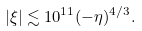Convert formula to latex. <formula><loc_0><loc_0><loc_500><loc_500>| \xi | \lesssim 1 0 ^ { 1 1 } ( - \eta ) ^ { 4 / 3 } .</formula> 